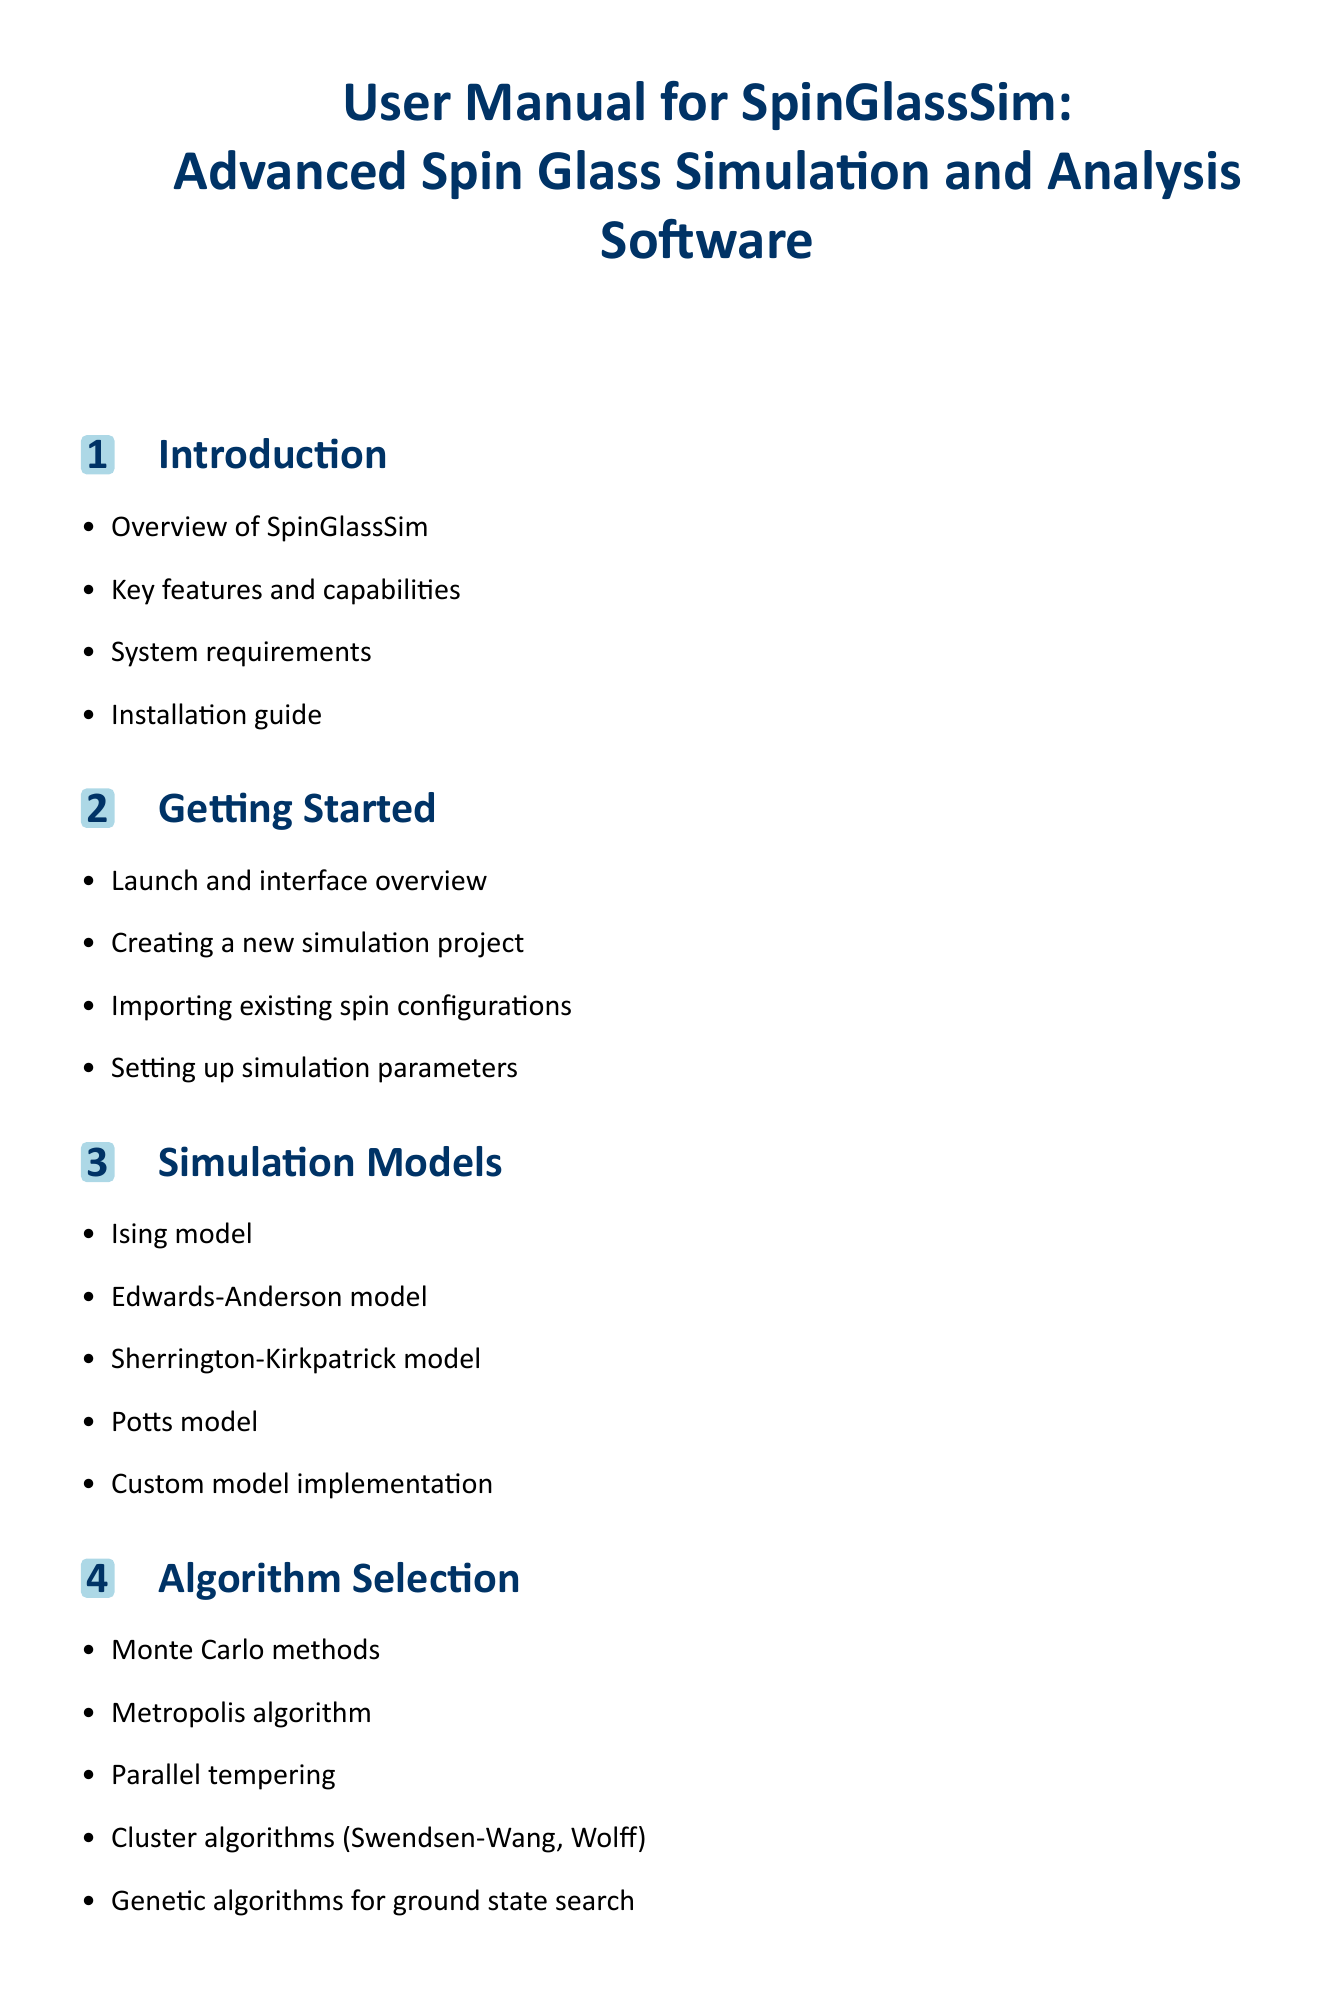What is the title of the software package? The title is mentioned at the beginning of the document and describes the software's purpose and its focus on advanced simulation and analysis.
Answer: User Manual for SpinGlassSim: Advanced Spin Glass Simulation and Analysis Software How many simulation models are listed in the document? The document outlines specific simulation models under a dedicated section, counting them gives the total number.
Answer: Five What algorithm is used for ground state search? The document includes a specific mention of an algorithm designed to find the ground state in spin systems.
Answer: Genetic algorithms What is the main function of the Data Analysis Tools section? The section describes various calculations and analyses tools that can be performed after simulations.
Answer: Energy and magnetization calculations Which section covers installation guide? The section that provides prerequisites and steps to install the software is crucial for new users.
Answer: Introduction What optimization technique is mentioned for large systems? The document lists strategies aimed at improving performance specifically for larger scale simulations.
Answer: Memory management What feature would allow customization of visual representation? The document mentions a way to create tailored visual elements for data representation.
Answer: Custom visualization scripts What external capability is mentioned for simulation running? The document outlines a specific technology that enhances computational speed during simulations.
Answer: GPU acceleration options What type of methods does the Advanced Features section discuss? The section emphasizes more complex techniques used in simulations beyond basic methods.
Answer: Replica exchange methods 